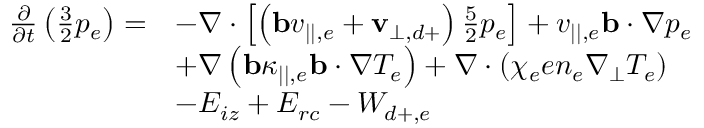Convert formula to latex. <formula><loc_0><loc_0><loc_500><loc_500>\begin{array} { r l } { \frac { \partial } { \partial t } \left ( \frac { 3 } { 2 } p _ { e } \right ) = } & { - \nabla \cdot \left [ \left ( b v _ { | | , e } + v _ { \perp , d + } \right ) \frac { 5 } { 2 } p _ { e } \right ] + v _ { | | , e } b \cdot \nabla p _ { e } } \\ & { + \nabla \left ( b \kappa _ { | | , e } b \cdot \nabla T _ { e } \right ) + \nabla \cdot \left ( \chi _ { e } e n _ { e } \nabla _ { \perp } T _ { e } \right ) } \\ & { - E _ { i z } + E _ { r c } - W _ { d + , e } } \end{array}</formula> 